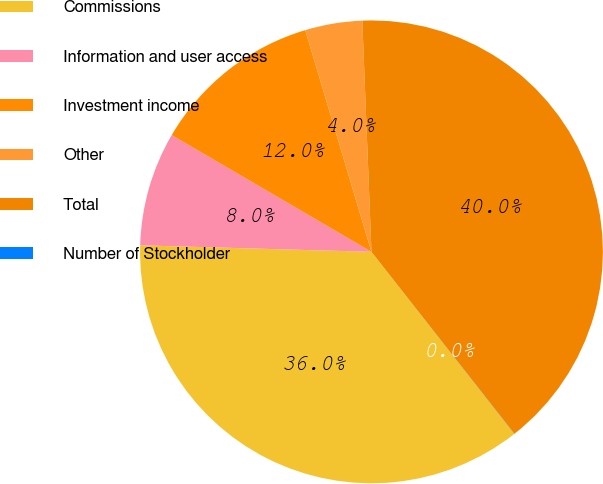<chart> <loc_0><loc_0><loc_500><loc_500><pie_chart><fcel>Commissions<fcel>Information and user access<fcel>Investment income<fcel>Other<fcel>Total<fcel>Number of Stockholder<nl><fcel>36.04%<fcel>7.97%<fcel>11.96%<fcel>3.99%<fcel>40.03%<fcel>0.01%<nl></chart> 